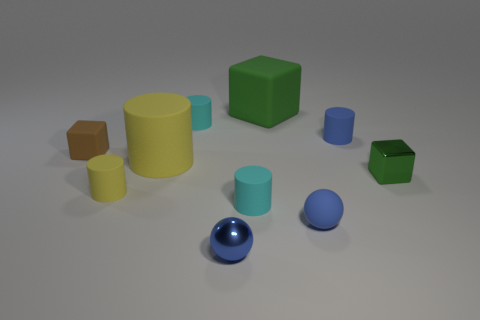Subtract 1 cylinders. How many cylinders are left? 4 Subtract all brown cylinders. Subtract all purple spheres. How many cylinders are left? 5 Subtract all blocks. How many objects are left? 7 Subtract all gray shiny balls. Subtract all big rubber cylinders. How many objects are left? 9 Add 1 blue matte things. How many blue matte things are left? 3 Add 5 tiny yellow objects. How many tiny yellow objects exist? 6 Subtract 0 red cubes. How many objects are left? 10 